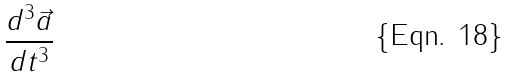Convert formula to latex. <formula><loc_0><loc_0><loc_500><loc_500>\frac { d ^ { 3 } \vec { a } } { d t ^ { 3 } }</formula> 